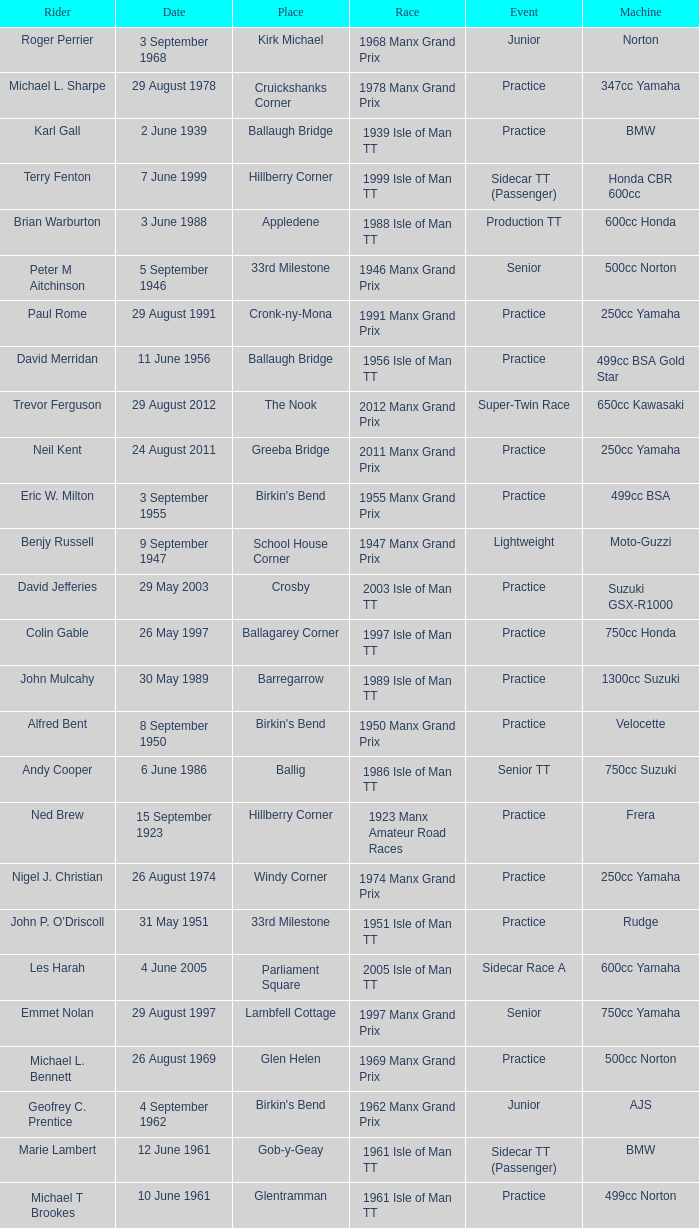What machine did Keith T. Gawler ride? 499cc Norton. 